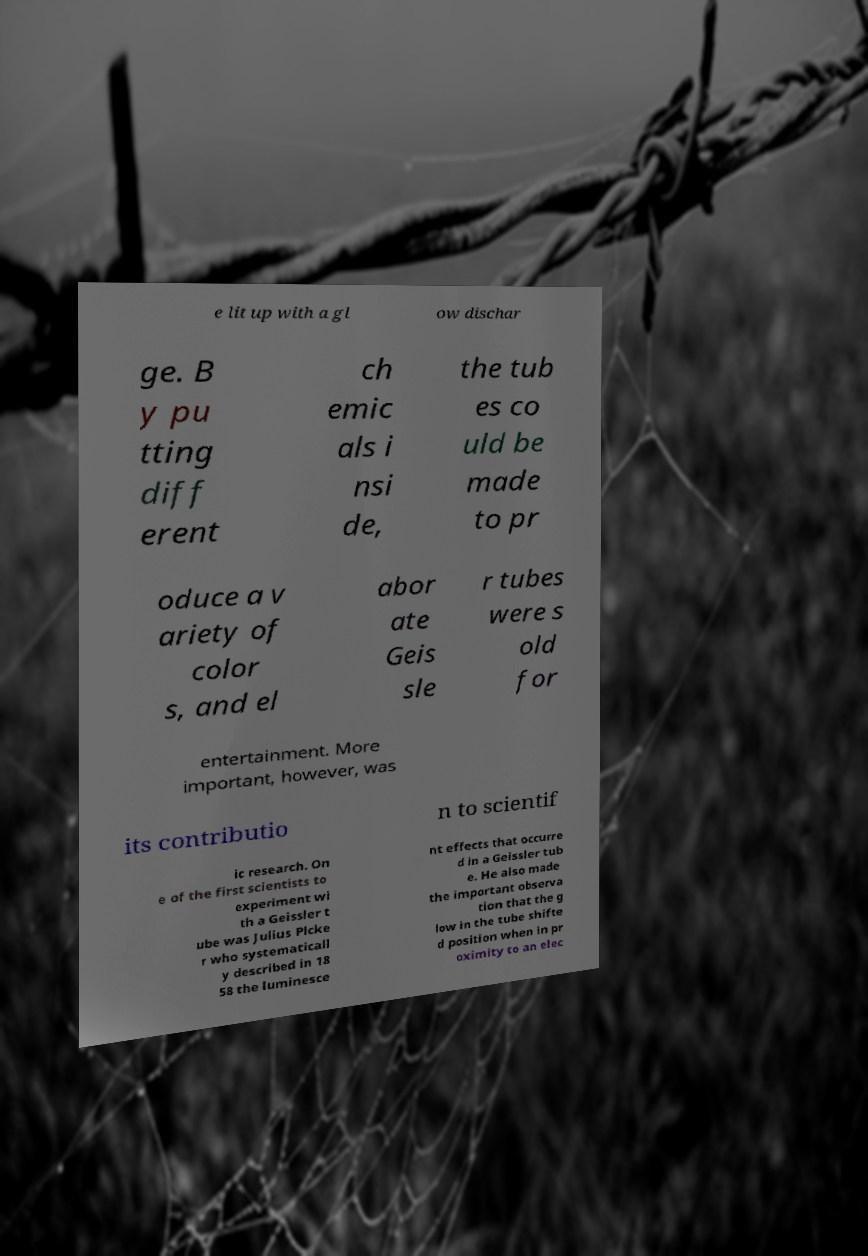I need the written content from this picture converted into text. Can you do that? e lit up with a gl ow dischar ge. B y pu tting diff erent ch emic als i nsi de, the tub es co uld be made to pr oduce a v ariety of color s, and el abor ate Geis sle r tubes were s old for entertainment. More important, however, was its contributio n to scientif ic research. On e of the first scientists to experiment wi th a Geissler t ube was Julius Plcke r who systematicall y described in 18 58 the luminesce nt effects that occurre d in a Geissler tub e. He also made the important observa tion that the g low in the tube shifte d position when in pr oximity to an elec 